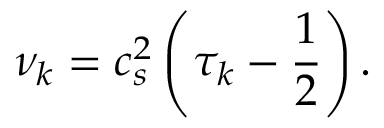<formula> <loc_0><loc_0><loc_500><loc_500>\nu _ { k } = c _ { s } ^ { 2 } \left ( \tau _ { k } - \frac { 1 } { 2 } \right ) .</formula> 